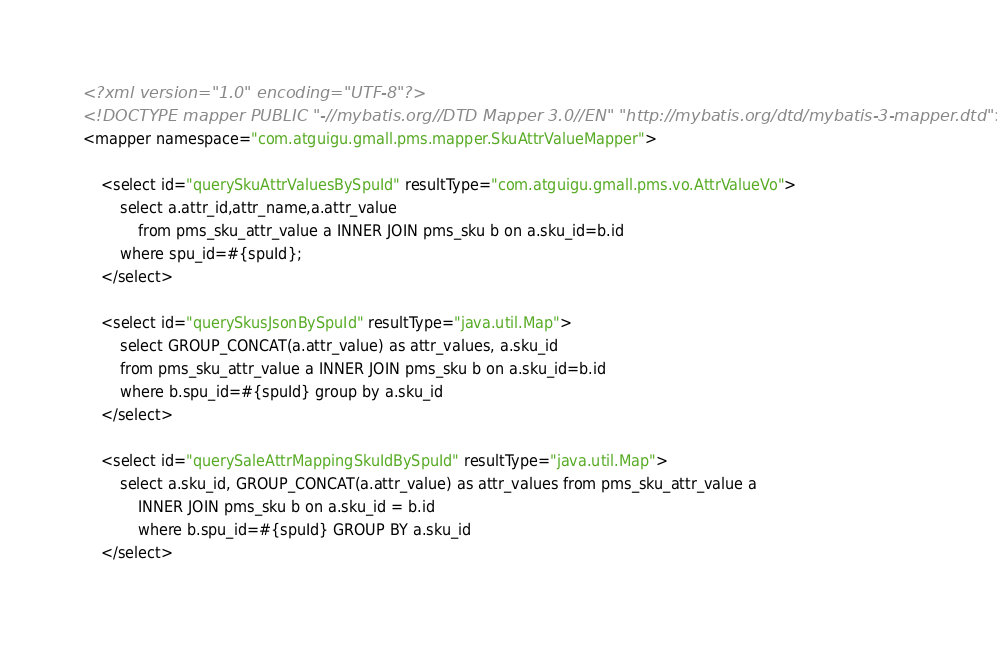<code> <loc_0><loc_0><loc_500><loc_500><_XML_><?xml version="1.0" encoding="UTF-8"?>
<!DOCTYPE mapper PUBLIC "-//mybatis.org//DTD Mapper 3.0//EN" "http://mybatis.org/dtd/mybatis-3-mapper.dtd">
<mapper namespace="com.atguigu.gmall.pms.mapper.SkuAttrValueMapper">

    <select id="querySkuAttrValuesBySpuId" resultType="com.atguigu.gmall.pms.vo.AttrValueVo">
        select a.attr_id,attr_name,a.attr_value
            from pms_sku_attr_value a INNER JOIN pms_sku b on a.sku_id=b.id
        where spu_id=#{spuId};
    </select>

    <select id="querySkusJsonBySpuId" resultType="java.util.Map">
        select GROUP_CONCAT(a.attr_value) as attr_values, a.sku_id
        from pms_sku_attr_value a INNER JOIN pms_sku b on a.sku_id=b.id
        where b.spu_id=#{spuId} group by a.sku_id
    </select>

    <select id="querySaleAttrMappingSkuIdBySpuId" resultType="java.util.Map">
        select a.sku_id, GROUP_CONCAT(a.attr_value) as attr_values from pms_sku_attr_value a
            INNER JOIN pms_sku b on a.sku_id = b.id
            where b.spu_id=#{spuId} GROUP BY a.sku_id
    </select></code> 